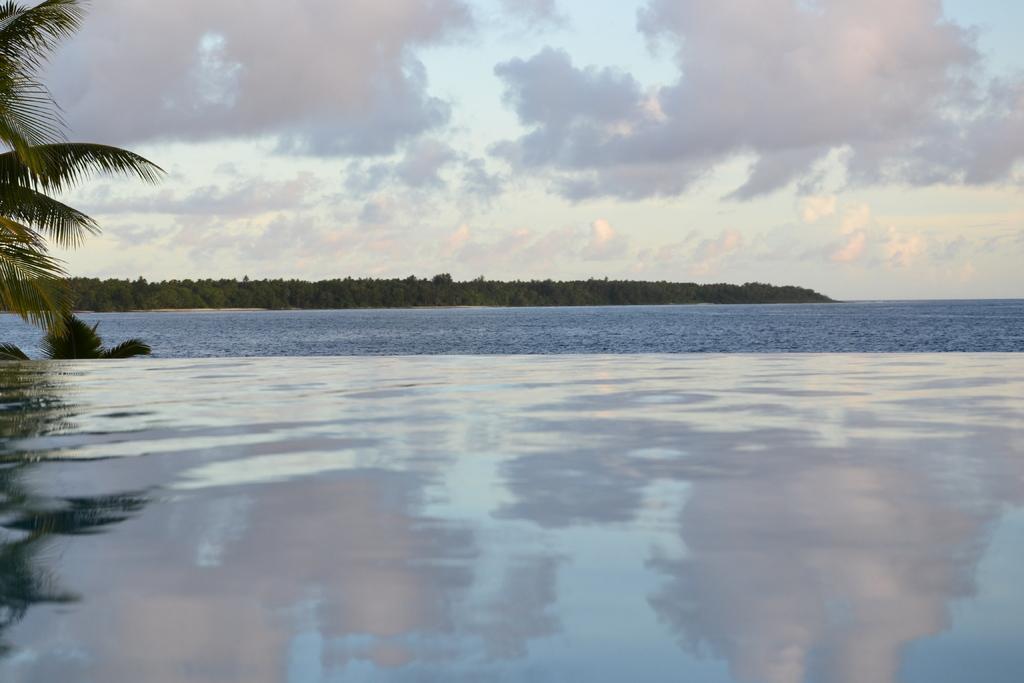In one or two sentences, can you explain what this image depicts? In this image at the bottom, there are waves and water. On the left there are trees. In the background there are trees, water, sky and clouds. 